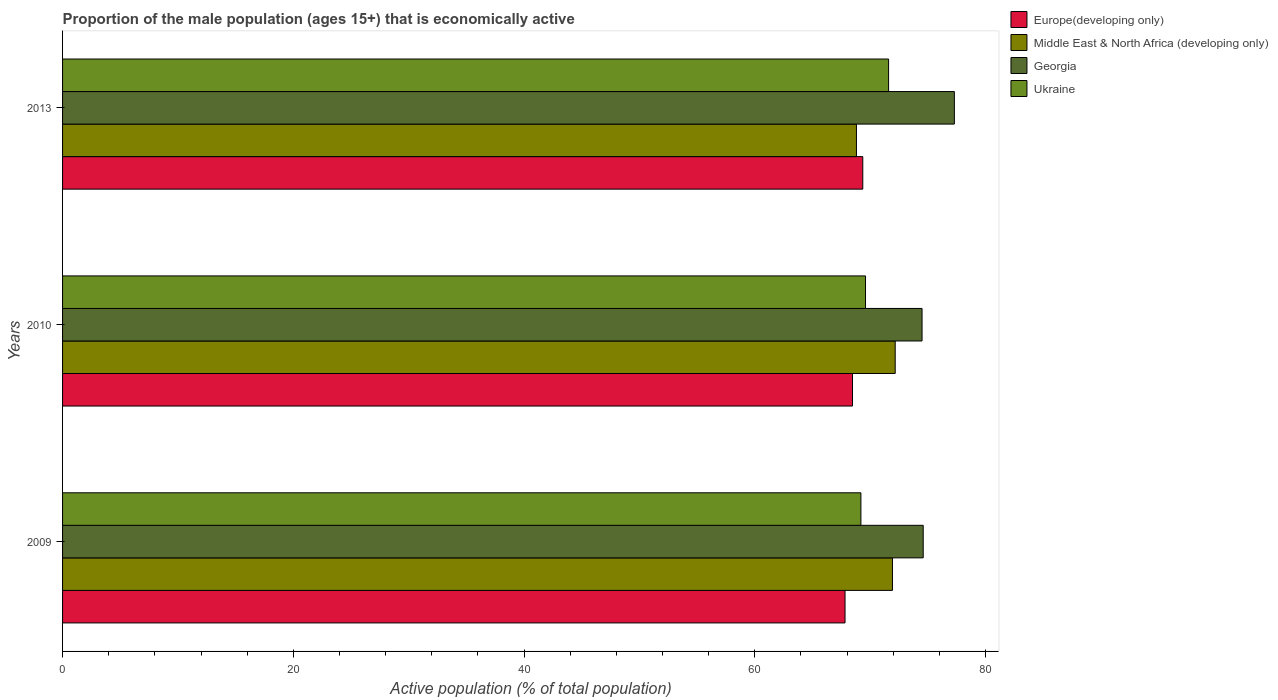How many different coloured bars are there?
Your answer should be very brief. 4. Are the number of bars per tick equal to the number of legend labels?
Give a very brief answer. Yes. How many bars are there on the 1st tick from the bottom?
Give a very brief answer. 4. What is the label of the 2nd group of bars from the top?
Provide a short and direct response. 2010. What is the proportion of the male population that is economically active in Europe(developing only) in 2013?
Offer a very short reply. 69.36. Across all years, what is the maximum proportion of the male population that is economically active in Middle East & North Africa (developing only)?
Provide a short and direct response. 72.17. Across all years, what is the minimum proportion of the male population that is economically active in Middle East & North Africa (developing only)?
Offer a terse response. 68.81. In which year was the proportion of the male population that is economically active in Ukraine maximum?
Your response must be concise. 2013. In which year was the proportion of the male population that is economically active in Europe(developing only) minimum?
Offer a terse response. 2009. What is the total proportion of the male population that is economically active in Europe(developing only) in the graph?
Your answer should be very brief. 205.66. What is the difference between the proportion of the male population that is economically active in Ukraine in 2009 and that in 2013?
Provide a succinct answer. -2.4. What is the difference between the proportion of the male population that is economically active in Ukraine in 2009 and the proportion of the male population that is economically active in Middle East & North Africa (developing only) in 2013?
Provide a short and direct response. 0.39. What is the average proportion of the male population that is economically active in Georgia per year?
Ensure brevity in your answer.  75.47. In the year 2009, what is the difference between the proportion of the male population that is economically active in Georgia and proportion of the male population that is economically active in Europe(developing only)?
Provide a short and direct response. 6.78. In how many years, is the proportion of the male population that is economically active in Middle East & North Africa (developing only) greater than 40 %?
Offer a very short reply. 3. What is the ratio of the proportion of the male population that is economically active in Ukraine in 2009 to that in 2010?
Give a very brief answer. 0.99. What is the difference between the highest and the second highest proportion of the male population that is economically active in Georgia?
Ensure brevity in your answer.  2.7. What is the difference between the highest and the lowest proportion of the male population that is economically active in Georgia?
Provide a short and direct response. 2.8. In how many years, is the proportion of the male population that is economically active in Middle East & North Africa (developing only) greater than the average proportion of the male population that is economically active in Middle East & North Africa (developing only) taken over all years?
Your response must be concise. 2. Is the sum of the proportion of the male population that is economically active in Georgia in 2010 and 2013 greater than the maximum proportion of the male population that is economically active in Europe(developing only) across all years?
Provide a succinct answer. Yes. What does the 1st bar from the top in 2013 represents?
Keep it short and to the point. Ukraine. What does the 1st bar from the bottom in 2010 represents?
Keep it short and to the point. Europe(developing only). Is it the case that in every year, the sum of the proportion of the male population that is economically active in Ukraine and proportion of the male population that is economically active in Europe(developing only) is greater than the proportion of the male population that is economically active in Middle East & North Africa (developing only)?
Your response must be concise. Yes. Are all the bars in the graph horizontal?
Keep it short and to the point. Yes. What is the difference between two consecutive major ticks on the X-axis?
Provide a succinct answer. 20. Are the values on the major ticks of X-axis written in scientific E-notation?
Ensure brevity in your answer.  No. Where does the legend appear in the graph?
Your answer should be compact. Top right. What is the title of the graph?
Provide a short and direct response. Proportion of the male population (ages 15+) that is economically active. Does "Australia" appear as one of the legend labels in the graph?
Make the answer very short. No. What is the label or title of the X-axis?
Your response must be concise. Active population (% of total population). What is the Active population (% of total population) of Europe(developing only) in 2009?
Give a very brief answer. 67.82. What is the Active population (% of total population) of Middle East & North Africa (developing only) in 2009?
Offer a very short reply. 71.93. What is the Active population (% of total population) of Georgia in 2009?
Offer a terse response. 74.6. What is the Active population (% of total population) in Ukraine in 2009?
Provide a short and direct response. 69.2. What is the Active population (% of total population) in Europe(developing only) in 2010?
Make the answer very short. 68.47. What is the Active population (% of total population) in Middle East & North Africa (developing only) in 2010?
Your answer should be compact. 72.17. What is the Active population (% of total population) of Georgia in 2010?
Offer a very short reply. 74.5. What is the Active population (% of total population) in Ukraine in 2010?
Provide a short and direct response. 69.6. What is the Active population (% of total population) in Europe(developing only) in 2013?
Offer a very short reply. 69.36. What is the Active population (% of total population) of Middle East & North Africa (developing only) in 2013?
Your answer should be compact. 68.81. What is the Active population (% of total population) of Georgia in 2013?
Make the answer very short. 77.3. What is the Active population (% of total population) in Ukraine in 2013?
Give a very brief answer. 71.6. Across all years, what is the maximum Active population (% of total population) in Europe(developing only)?
Make the answer very short. 69.36. Across all years, what is the maximum Active population (% of total population) in Middle East & North Africa (developing only)?
Your answer should be very brief. 72.17. Across all years, what is the maximum Active population (% of total population) in Georgia?
Make the answer very short. 77.3. Across all years, what is the maximum Active population (% of total population) of Ukraine?
Your response must be concise. 71.6. Across all years, what is the minimum Active population (% of total population) in Europe(developing only)?
Keep it short and to the point. 67.82. Across all years, what is the minimum Active population (% of total population) of Middle East & North Africa (developing only)?
Ensure brevity in your answer.  68.81. Across all years, what is the minimum Active population (% of total population) in Georgia?
Keep it short and to the point. 74.5. Across all years, what is the minimum Active population (% of total population) of Ukraine?
Make the answer very short. 69.2. What is the total Active population (% of total population) in Europe(developing only) in the graph?
Provide a succinct answer. 205.66. What is the total Active population (% of total population) of Middle East & North Africa (developing only) in the graph?
Your response must be concise. 212.92. What is the total Active population (% of total population) in Georgia in the graph?
Ensure brevity in your answer.  226.4. What is the total Active population (% of total population) in Ukraine in the graph?
Give a very brief answer. 210.4. What is the difference between the Active population (% of total population) of Europe(developing only) in 2009 and that in 2010?
Your response must be concise. -0.65. What is the difference between the Active population (% of total population) of Middle East & North Africa (developing only) in 2009 and that in 2010?
Provide a succinct answer. -0.24. What is the difference between the Active population (% of total population) in Europe(developing only) in 2009 and that in 2013?
Ensure brevity in your answer.  -1.54. What is the difference between the Active population (% of total population) in Middle East & North Africa (developing only) in 2009 and that in 2013?
Ensure brevity in your answer.  3.12. What is the difference between the Active population (% of total population) of Europe(developing only) in 2010 and that in 2013?
Ensure brevity in your answer.  -0.89. What is the difference between the Active population (% of total population) of Middle East & North Africa (developing only) in 2010 and that in 2013?
Give a very brief answer. 3.36. What is the difference between the Active population (% of total population) in Georgia in 2010 and that in 2013?
Provide a short and direct response. -2.8. What is the difference between the Active population (% of total population) in Europe(developing only) in 2009 and the Active population (% of total population) in Middle East & North Africa (developing only) in 2010?
Your response must be concise. -4.35. What is the difference between the Active population (% of total population) of Europe(developing only) in 2009 and the Active population (% of total population) of Georgia in 2010?
Your response must be concise. -6.68. What is the difference between the Active population (% of total population) of Europe(developing only) in 2009 and the Active population (% of total population) of Ukraine in 2010?
Your answer should be compact. -1.78. What is the difference between the Active population (% of total population) in Middle East & North Africa (developing only) in 2009 and the Active population (% of total population) in Georgia in 2010?
Make the answer very short. -2.57. What is the difference between the Active population (% of total population) in Middle East & North Africa (developing only) in 2009 and the Active population (% of total population) in Ukraine in 2010?
Provide a short and direct response. 2.33. What is the difference between the Active population (% of total population) of Europe(developing only) in 2009 and the Active population (% of total population) of Middle East & North Africa (developing only) in 2013?
Ensure brevity in your answer.  -0.99. What is the difference between the Active population (% of total population) of Europe(developing only) in 2009 and the Active population (% of total population) of Georgia in 2013?
Offer a very short reply. -9.48. What is the difference between the Active population (% of total population) of Europe(developing only) in 2009 and the Active population (% of total population) of Ukraine in 2013?
Make the answer very short. -3.78. What is the difference between the Active population (% of total population) in Middle East & North Africa (developing only) in 2009 and the Active population (% of total population) in Georgia in 2013?
Your answer should be very brief. -5.37. What is the difference between the Active population (% of total population) in Middle East & North Africa (developing only) in 2009 and the Active population (% of total population) in Ukraine in 2013?
Give a very brief answer. 0.33. What is the difference between the Active population (% of total population) in Europe(developing only) in 2010 and the Active population (% of total population) in Middle East & North Africa (developing only) in 2013?
Your answer should be very brief. -0.34. What is the difference between the Active population (% of total population) in Europe(developing only) in 2010 and the Active population (% of total population) in Georgia in 2013?
Your answer should be very brief. -8.83. What is the difference between the Active population (% of total population) in Europe(developing only) in 2010 and the Active population (% of total population) in Ukraine in 2013?
Keep it short and to the point. -3.13. What is the difference between the Active population (% of total population) in Middle East & North Africa (developing only) in 2010 and the Active population (% of total population) in Georgia in 2013?
Your response must be concise. -5.13. What is the difference between the Active population (% of total population) in Middle East & North Africa (developing only) in 2010 and the Active population (% of total population) in Ukraine in 2013?
Your answer should be very brief. 0.57. What is the difference between the Active population (% of total population) in Georgia in 2010 and the Active population (% of total population) in Ukraine in 2013?
Keep it short and to the point. 2.9. What is the average Active population (% of total population) of Europe(developing only) per year?
Offer a very short reply. 68.55. What is the average Active population (% of total population) of Middle East & North Africa (developing only) per year?
Ensure brevity in your answer.  70.97. What is the average Active population (% of total population) in Georgia per year?
Ensure brevity in your answer.  75.47. What is the average Active population (% of total population) in Ukraine per year?
Your response must be concise. 70.13. In the year 2009, what is the difference between the Active population (% of total population) of Europe(developing only) and Active population (% of total population) of Middle East & North Africa (developing only)?
Keep it short and to the point. -4.11. In the year 2009, what is the difference between the Active population (% of total population) in Europe(developing only) and Active population (% of total population) in Georgia?
Give a very brief answer. -6.78. In the year 2009, what is the difference between the Active population (% of total population) in Europe(developing only) and Active population (% of total population) in Ukraine?
Offer a terse response. -1.38. In the year 2009, what is the difference between the Active population (% of total population) in Middle East & North Africa (developing only) and Active population (% of total population) in Georgia?
Your answer should be very brief. -2.67. In the year 2009, what is the difference between the Active population (% of total population) in Middle East & North Africa (developing only) and Active population (% of total population) in Ukraine?
Your answer should be very brief. 2.73. In the year 2009, what is the difference between the Active population (% of total population) in Georgia and Active population (% of total population) in Ukraine?
Provide a succinct answer. 5.4. In the year 2010, what is the difference between the Active population (% of total population) of Europe(developing only) and Active population (% of total population) of Middle East & North Africa (developing only)?
Your response must be concise. -3.7. In the year 2010, what is the difference between the Active population (% of total population) in Europe(developing only) and Active population (% of total population) in Georgia?
Your response must be concise. -6.03. In the year 2010, what is the difference between the Active population (% of total population) in Europe(developing only) and Active population (% of total population) in Ukraine?
Your answer should be very brief. -1.13. In the year 2010, what is the difference between the Active population (% of total population) of Middle East & North Africa (developing only) and Active population (% of total population) of Georgia?
Your answer should be very brief. -2.33. In the year 2010, what is the difference between the Active population (% of total population) in Middle East & North Africa (developing only) and Active population (% of total population) in Ukraine?
Keep it short and to the point. 2.57. In the year 2010, what is the difference between the Active population (% of total population) in Georgia and Active population (% of total population) in Ukraine?
Make the answer very short. 4.9. In the year 2013, what is the difference between the Active population (% of total population) of Europe(developing only) and Active population (% of total population) of Middle East & North Africa (developing only)?
Offer a terse response. 0.55. In the year 2013, what is the difference between the Active population (% of total population) in Europe(developing only) and Active population (% of total population) in Georgia?
Your answer should be compact. -7.94. In the year 2013, what is the difference between the Active population (% of total population) of Europe(developing only) and Active population (% of total population) of Ukraine?
Your response must be concise. -2.24. In the year 2013, what is the difference between the Active population (% of total population) in Middle East & North Africa (developing only) and Active population (% of total population) in Georgia?
Offer a very short reply. -8.49. In the year 2013, what is the difference between the Active population (% of total population) in Middle East & North Africa (developing only) and Active population (% of total population) in Ukraine?
Provide a short and direct response. -2.79. What is the ratio of the Active population (% of total population) in Europe(developing only) in 2009 to that in 2010?
Offer a terse response. 0.99. What is the ratio of the Active population (% of total population) of Middle East & North Africa (developing only) in 2009 to that in 2010?
Provide a short and direct response. 1. What is the ratio of the Active population (% of total population) in Georgia in 2009 to that in 2010?
Give a very brief answer. 1. What is the ratio of the Active population (% of total population) in Europe(developing only) in 2009 to that in 2013?
Offer a terse response. 0.98. What is the ratio of the Active population (% of total population) in Middle East & North Africa (developing only) in 2009 to that in 2013?
Your response must be concise. 1.05. What is the ratio of the Active population (% of total population) of Georgia in 2009 to that in 2013?
Offer a very short reply. 0.97. What is the ratio of the Active population (% of total population) of Ukraine in 2009 to that in 2013?
Ensure brevity in your answer.  0.97. What is the ratio of the Active population (% of total population) in Europe(developing only) in 2010 to that in 2013?
Your answer should be very brief. 0.99. What is the ratio of the Active population (% of total population) of Middle East & North Africa (developing only) in 2010 to that in 2013?
Your answer should be very brief. 1.05. What is the ratio of the Active population (% of total population) of Georgia in 2010 to that in 2013?
Your answer should be very brief. 0.96. What is the ratio of the Active population (% of total population) in Ukraine in 2010 to that in 2013?
Your answer should be compact. 0.97. What is the difference between the highest and the second highest Active population (% of total population) in Europe(developing only)?
Provide a short and direct response. 0.89. What is the difference between the highest and the second highest Active population (% of total population) of Middle East & North Africa (developing only)?
Ensure brevity in your answer.  0.24. What is the difference between the highest and the second highest Active population (% of total population) in Georgia?
Make the answer very short. 2.7. What is the difference between the highest and the lowest Active population (% of total population) in Europe(developing only)?
Provide a short and direct response. 1.54. What is the difference between the highest and the lowest Active population (% of total population) in Middle East & North Africa (developing only)?
Ensure brevity in your answer.  3.36. What is the difference between the highest and the lowest Active population (% of total population) in Georgia?
Your answer should be very brief. 2.8. What is the difference between the highest and the lowest Active population (% of total population) in Ukraine?
Offer a very short reply. 2.4. 